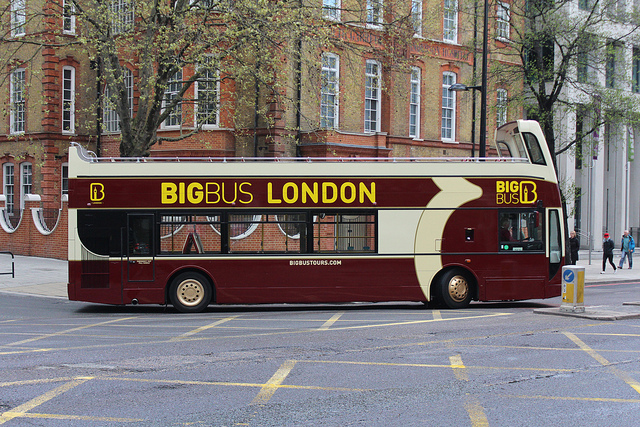Please extract the text content from this image. BIGBUS LONDON BIGBUS B B 